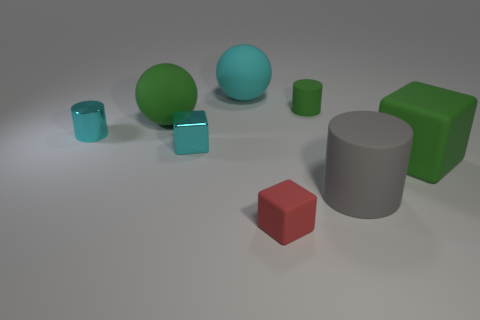What is the shape of the gray rubber thing?
Provide a succinct answer. Cylinder. How many red objects are the same material as the red block?
Offer a very short reply. 0. What color is the other big ball that is made of the same material as the large cyan sphere?
Your response must be concise. Green. Do the cyan metallic cube and the matte sphere in front of the cyan matte sphere have the same size?
Make the answer very short. No. There is a cube that is right of the tiny red rubber cube on the left side of the large green object to the right of the big green rubber sphere; what is it made of?
Provide a succinct answer. Rubber. What number of objects are either big brown shiny cylinders or cyan metallic things?
Keep it short and to the point. 2. There is a big object that is to the left of the small cyan block; is its color the same as the big matte ball to the right of the green matte ball?
Ensure brevity in your answer.  No. What shape is the shiny object that is the same size as the cyan shiny cube?
Give a very brief answer. Cylinder. What number of things are matte cubes in front of the gray matte cylinder or big things behind the tiny cyan metal cube?
Give a very brief answer. 3. Is the number of gray shiny spheres less than the number of green rubber balls?
Your response must be concise. Yes. 